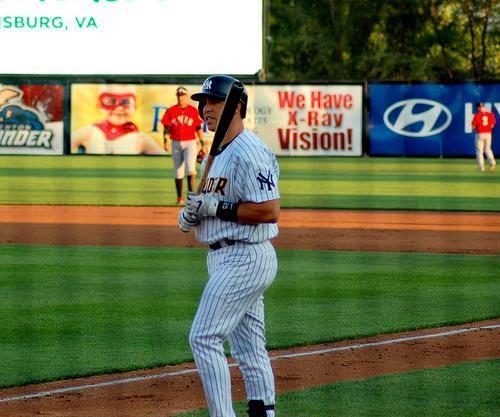How many batters are in the photo?
Give a very brief answer. 1. 